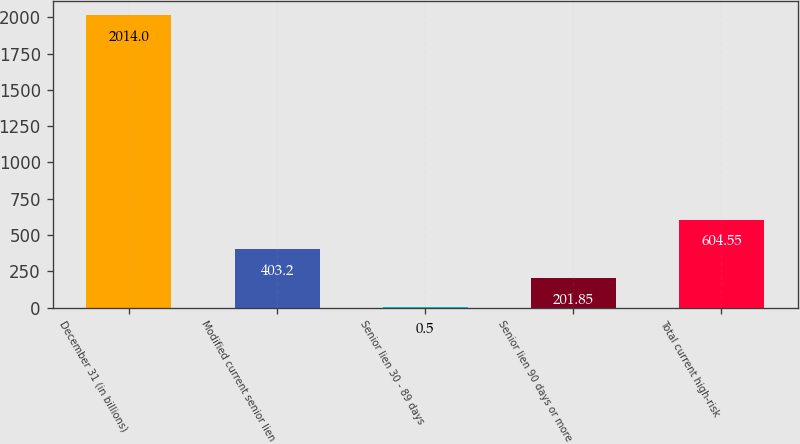Convert chart. <chart><loc_0><loc_0><loc_500><loc_500><bar_chart><fcel>December 31 (in billions)<fcel>Modified current senior lien<fcel>Senior lien 30 - 89 days<fcel>Senior lien 90 days or more<fcel>Total current high-risk<nl><fcel>2014<fcel>403.2<fcel>0.5<fcel>201.85<fcel>604.55<nl></chart> 